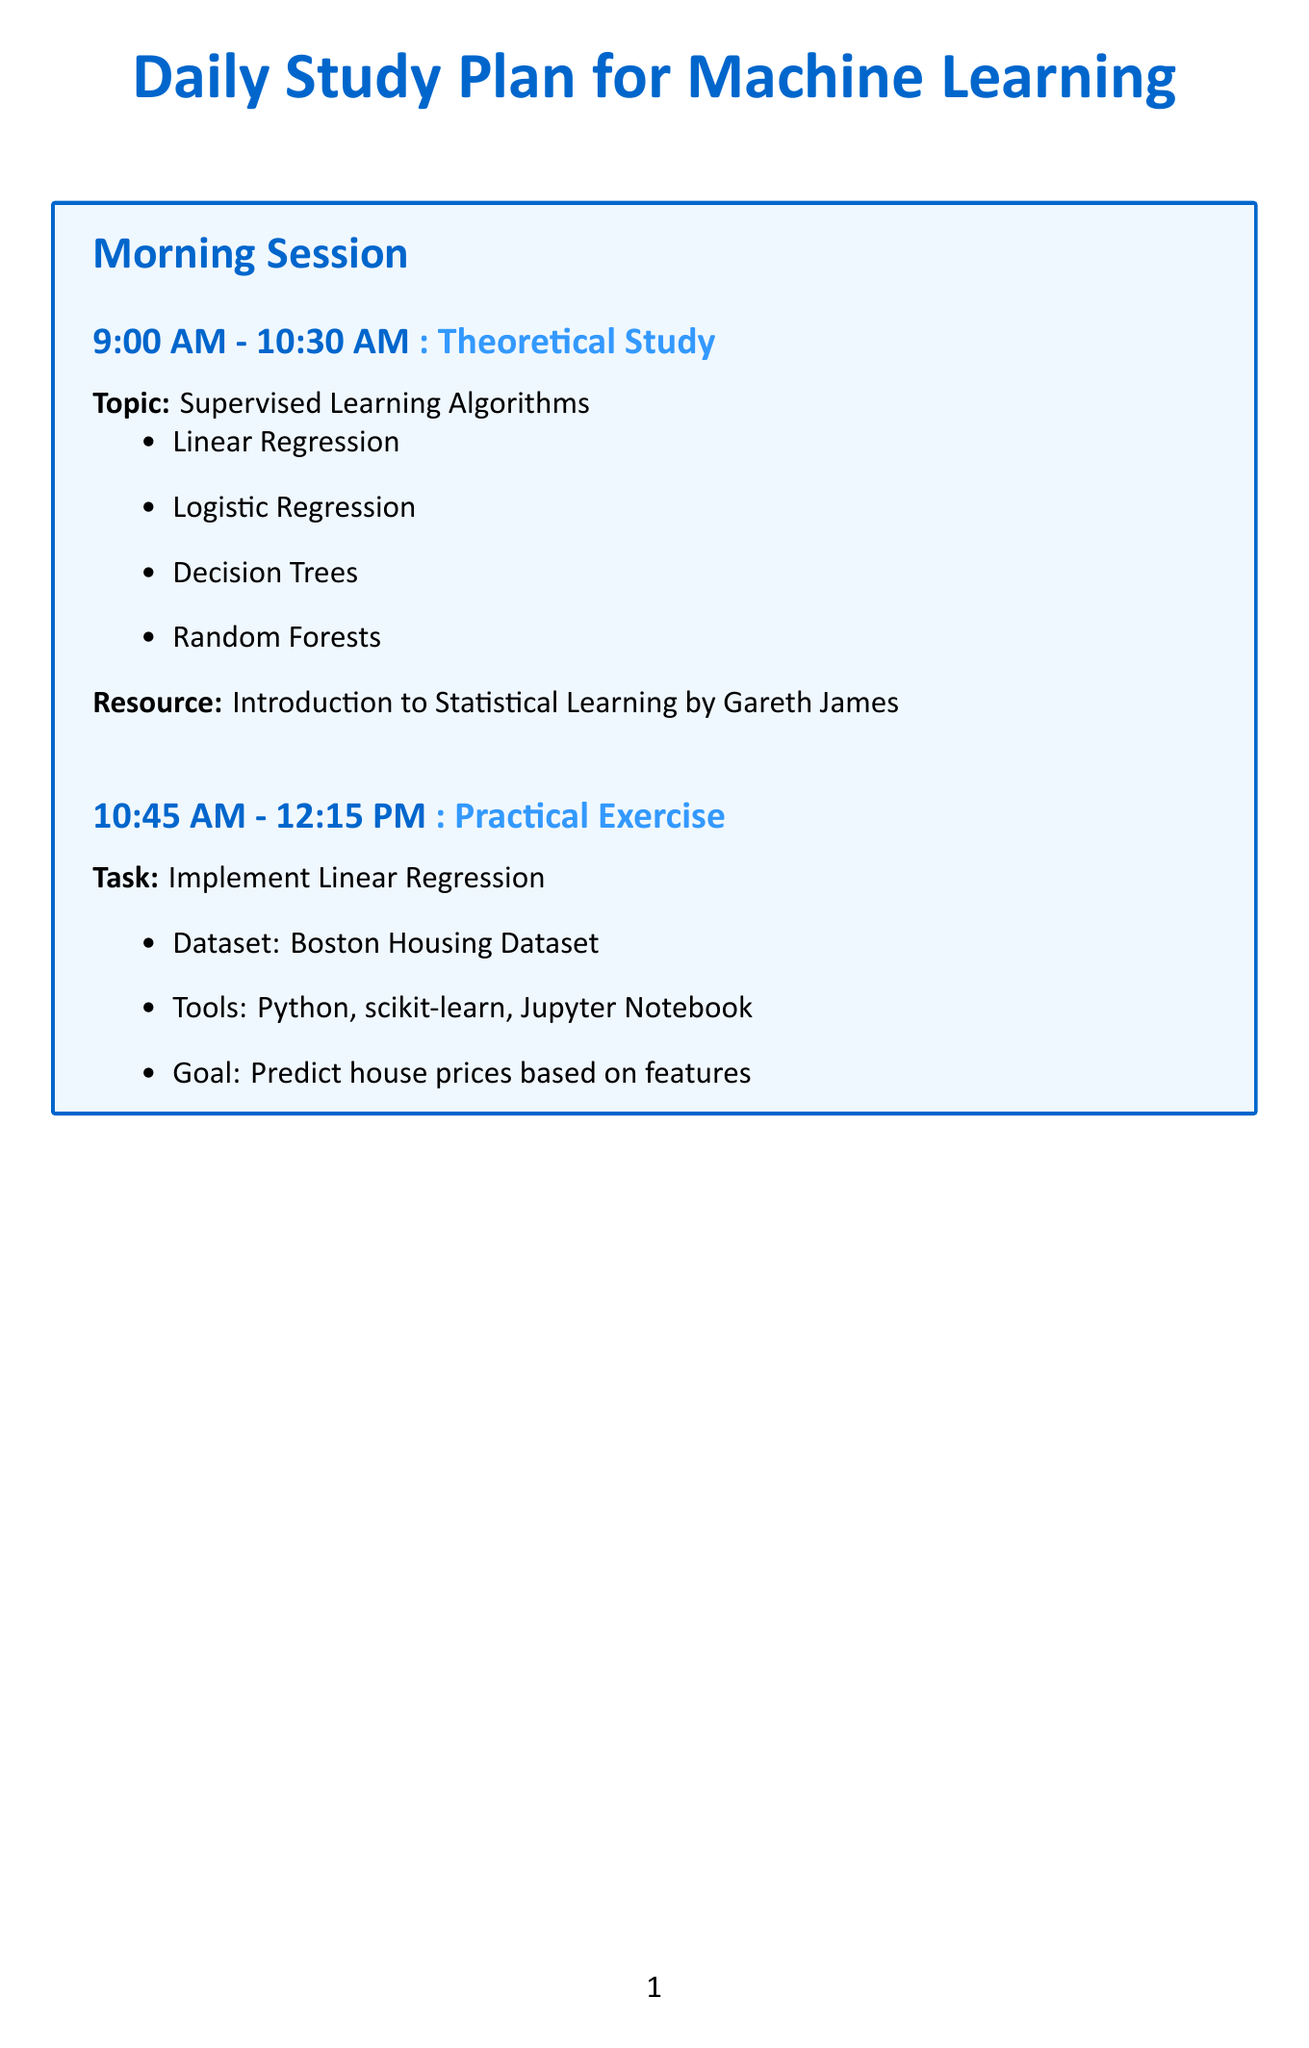What is the first topic for theoretical study? The document lists Supervised Learning Algorithms as the first theoretical study topic.
Answer: Supervised Learning Algorithms What is the time block for implementing K-means Clustering? The time block for K-means Clustering practical exercise is indicated in the afternoon session.
Answer: 3:15 PM - 4:45 PM Which dataset is used for the practical exercise of Linear Regression? The document specifies the Boston Housing Dataset for the Linear Regression task.
Answer: Boston Housing Dataset Who is the instructor for the Deep Learning Specialization course? The document provides the name of the instructor for the online course as Andrew Ng.
Answer: Andrew Ng What is the focus area of the research paper reviewed in the evening? The document outlines several focus areas for the research paper "Attention Is All You Need".
Answer: Transformer architecture How long is the practical exercise for implementing Linear Regression? The length of the practical exercise for Linear Regression is mentioned in the time block section.
Answer: 1 hour 30 minutes What activity follows the theoretical study of Unsupervised Learning Algorithms? The schedule indicates that there is a practical exercise after the theoretical study of Unsupervised Learning Algorithms.
Answer: Practical Exercise What is the primary goal of the K-means Clustering implementation? The document states that the goal is to cluster iris flowers based on their features.
Answer: Cluster iris flowers based on their features 